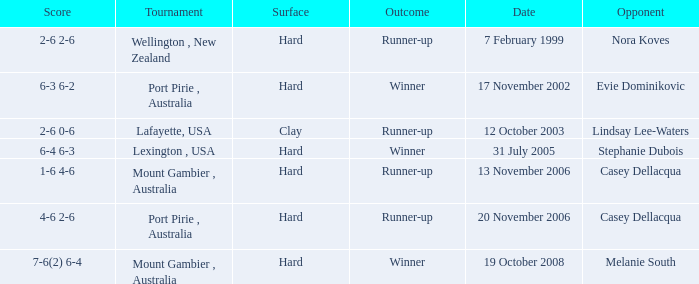When is an Opponent of evie dominikovic? 17 November 2002. 